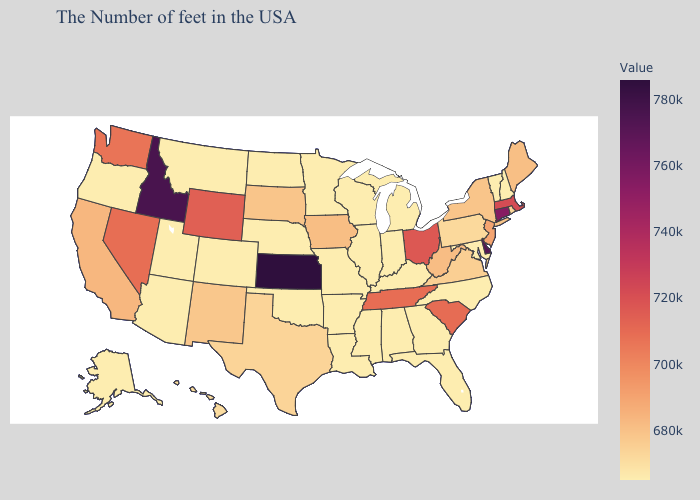Among the states that border Wyoming , does Idaho have the highest value?
Give a very brief answer. Yes. Does Kansas have the highest value in the USA?
Concise answer only. Yes. Among the states that border California , which have the lowest value?
Be succinct. Arizona, Oregon. Which states have the lowest value in the USA?
Keep it brief. New Hampshire, Vermont, Maryland, North Carolina, Florida, Georgia, Michigan, Kentucky, Indiana, Alabama, Wisconsin, Illinois, Mississippi, Louisiana, Missouri, Arkansas, Minnesota, Nebraska, Oklahoma, North Dakota, Colorado, Utah, Montana, Arizona, Oregon, Alaska. Which states hav the highest value in the West?
Answer briefly. Idaho. Does Oklahoma have a higher value than Tennessee?
Quick response, please. No. 